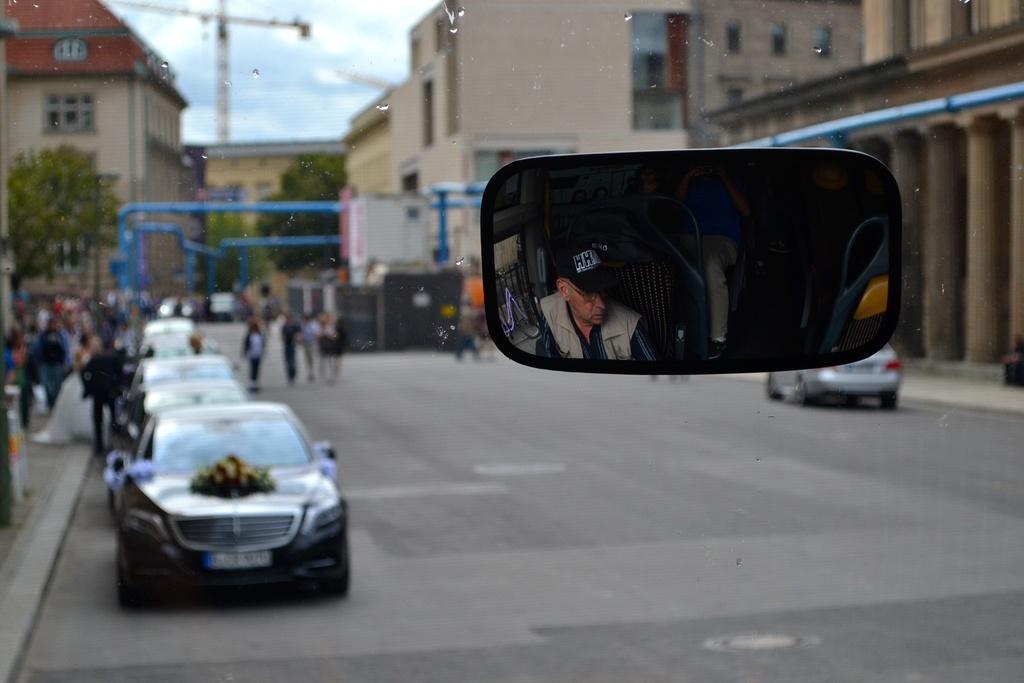Can you describe this image briefly? This image is taken from the rear view mirror of a bus, from the mirror, we can see there is a driver in the driver seat, in front of the bus on the road there are few cars parked and there are few people walking on the road and on the pavement as well,in the background of the image there are trees and buildings. 